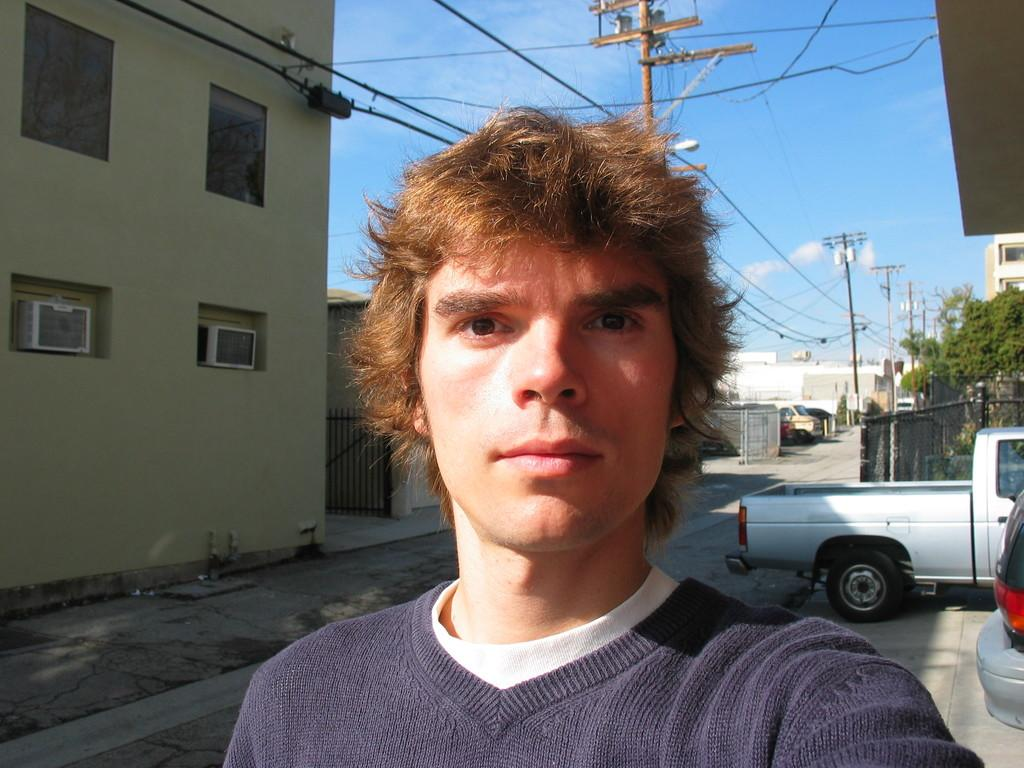Who or what is present in the image? There is a person in the image. What else can be seen in the image besides the person? There are vehicles, buildings, electric poles and cables, and fences in the image. What is visible in the sky in the image? There are clouds in the sky. What color are the person's eyes in the image? The provided facts do not mention the person's eyes, so we cannot determine their color from the image. 